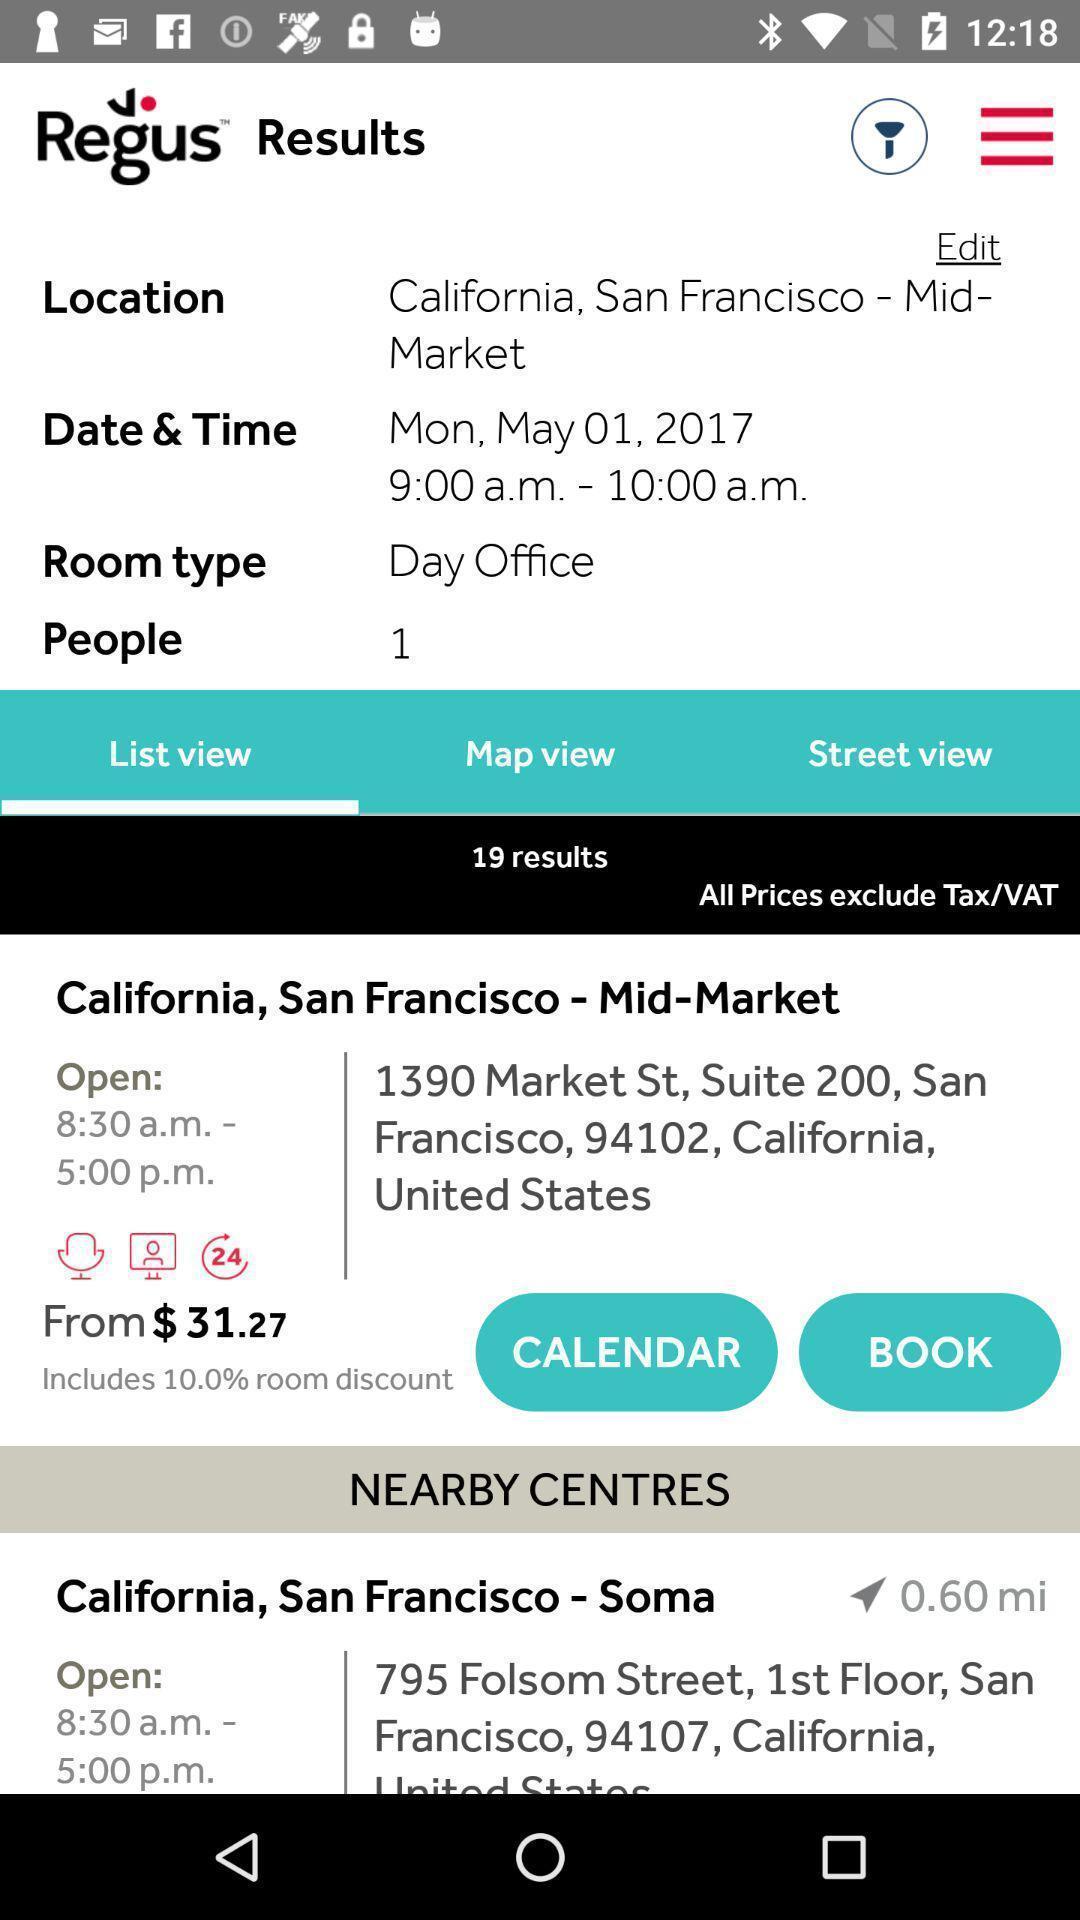Provide a description of this screenshot. Screen shows the details about workspace. 